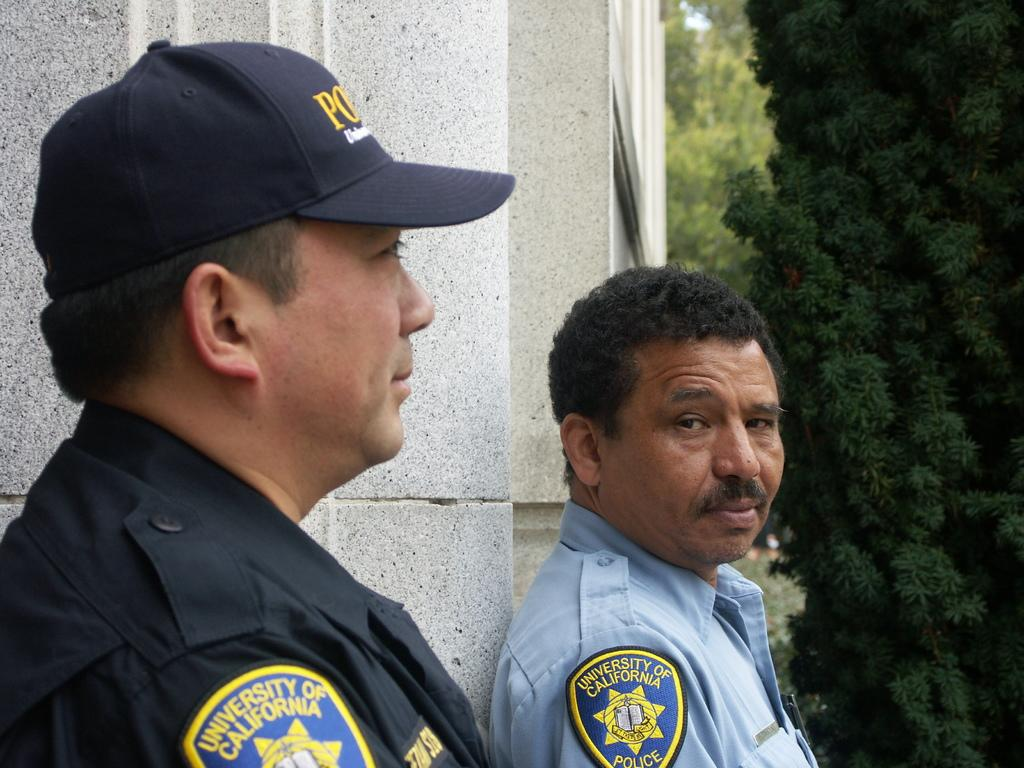How many people are in the image? There are two persons in the image. Can you describe the clothing details be observed on one of the persons? Yes, one of the persons is wearing a cap. What type of natural scenery is visible in the background of the image? There are trees in the background of the image. What type of crime is being committed in the image? There is no crime being committed in the image; it features two people and trees in the background. Can you describe the sea visible in the image? There is no sea present in the image; it only features trees in the background. 